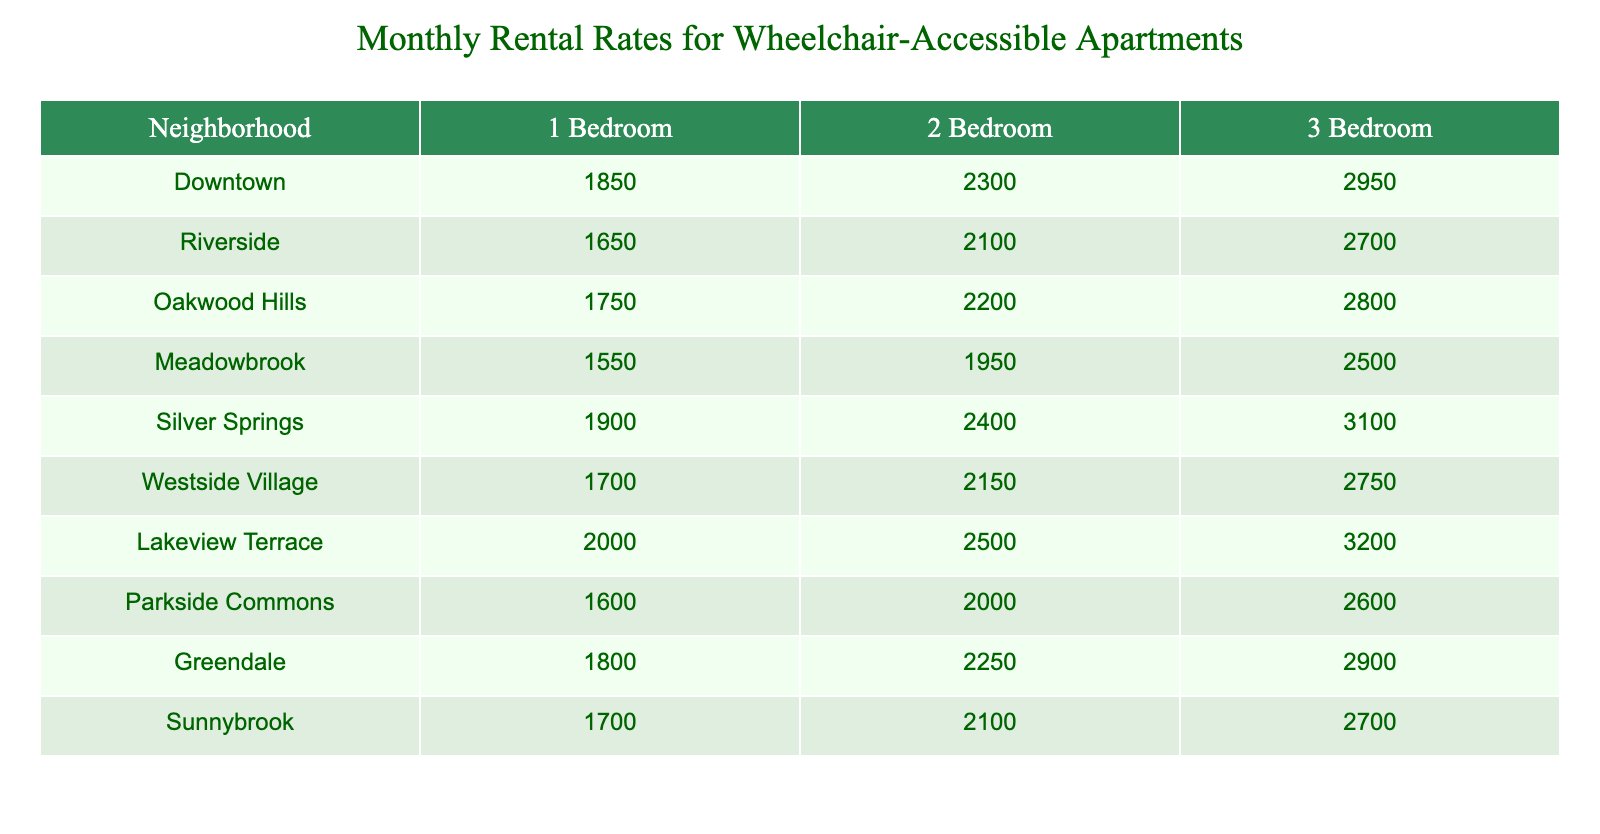What is the monthly rental rate for a 2-bedroom apartment in Downtown? According to the table, the monthly rental rate for a 2-bedroom apartment in Downtown is listed as 2300.
Answer: 2300 Which neighborhood has the lowest rental rate for a 1-bedroom apartment? The table shows that Meadowbrook has the lowest rental rate of 1550 for a 1-bedroom apartment.
Answer: Meadowbrook What is the average monthly rental rate for a 3-bedroom apartment across all neighborhoods? To find the average, we sum the 3-bedroom rental rates: (2950 + 2700 + 2800 + 2500 + 3100 + 2750 + 3200 + 2600 + 2900 + 2700) = 28100, and divide by 10 (the number of neighborhoods): 28100 / 10 = 2810.
Answer: 2810 Is the rental rate for a 3-bedroom apartment in Silver Springs higher than in Riverside? The table shows that the rental rate for a 3-bedroom apartment in Silver Springs is 3100, while in Riverside it is 2700. Since 3100 is greater than 2700, the answer is yes.
Answer: Yes Which neighborhood offers the highest rental rate for a 1-bedroom apartment, and what is that rate? The table states that Lakeview Terrace has the highest rental rate for a 1-bedroom apartment at 2000.
Answer: Lakeview Terrace, 2000 What is the difference in rental rates between a 2-bedroom apartment in Oakwood Hills and a 3-bedroom apartment in Parkside Commons? The rental rate for a 2-bedroom in Oakwood Hills is 2200, and the rate for a 3-bedroom in Parkside Commons is 2600. The difference is calculated as 2600 - 2200 = 400.
Answer: 400 How many neighborhoods have a 1-bedroom rental rate above 1800? According to the table, the neighborhoods with a 1-bedroom rental rate above 1800 are Downtown (1850), Oakwood Hills (1750), Silver Springs (1900), Lakeview Terrace (2000), Greendale (1800). There are 6 neighborhoods: Downtown, Riverside, Lakeview Terrace, Silver Springs, and Greendale. Therefore, the answer is 5 neighborhoods.
Answer: 5 What is the median rental rate for 2-bedroom apartments across the neighborhoods? To find the median, we first list the rental rates for 2-bedroom apartments in increasing order: 1950 (Meadowbrook), 2000 (Parkside Commons), 2100 (Riverside, Sunnybrook), 2150 (Westside Village), 2200 (Oakwood Hills), 2250 (Greendale), 2300 (Downtown), 2400 (Silver Springs), 2500 (Lakeview Terrace). With 10 data points, the median is the average of the 5th and 6th values: (2150 + 2200) / 2 = 2175.
Answer: 2175 Which neighborhood has the closest rental rates for a 2-bedroom and 3-bedroom apartment? Looking at the table, we can compare the differences: Downtown (2300 - 2950 = 650), Riverside (2100 - 2700 = 600), Oakwood Hills (2200 - 2800 = 600), Meadowbrook (1950 - 2500 = 550), Silver Springs (2400 - 3100 = 700), Westside Village (2150 - 2750 = 600), Lakeview Terrace (2500 - 3200 = 700), Parkside Commons (2000 - 2600 = 600), Greendale (2250 - 2900 = 650), Sunnybrook (2100 - 2700 = 600). The smallest difference of 550 is found in Meadowbrook.
Answer: Meadowbrook 